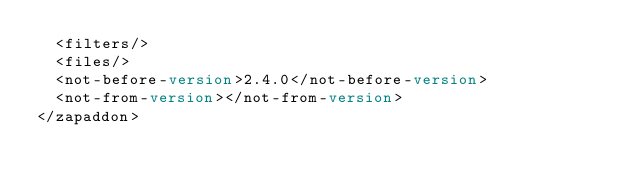<code> <loc_0><loc_0><loc_500><loc_500><_XML_>	<filters/>
	<files/>
	<not-before-version>2.4.0</not-before-version>
	<not-from-version></not-from-version>
</zapaddon>

</code> 